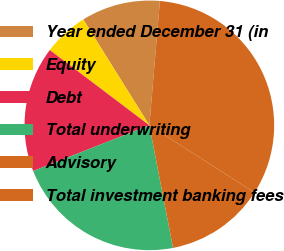Convert chart. <chart><loc_0><loc_0><loc_500><loc_500><pie_chart><fcel>Year ended December 31 (in<fcel>Equity<fcel>Debt<fcel>Total underwriting<fcel>Advisory<fcel>Total investment banking fees<nl><fcel>10.23%<fcel>5.81%<fcel>16.27%<fcel>22.08%<fcel>12.91%<fcel>32.7%<nl></chart> 